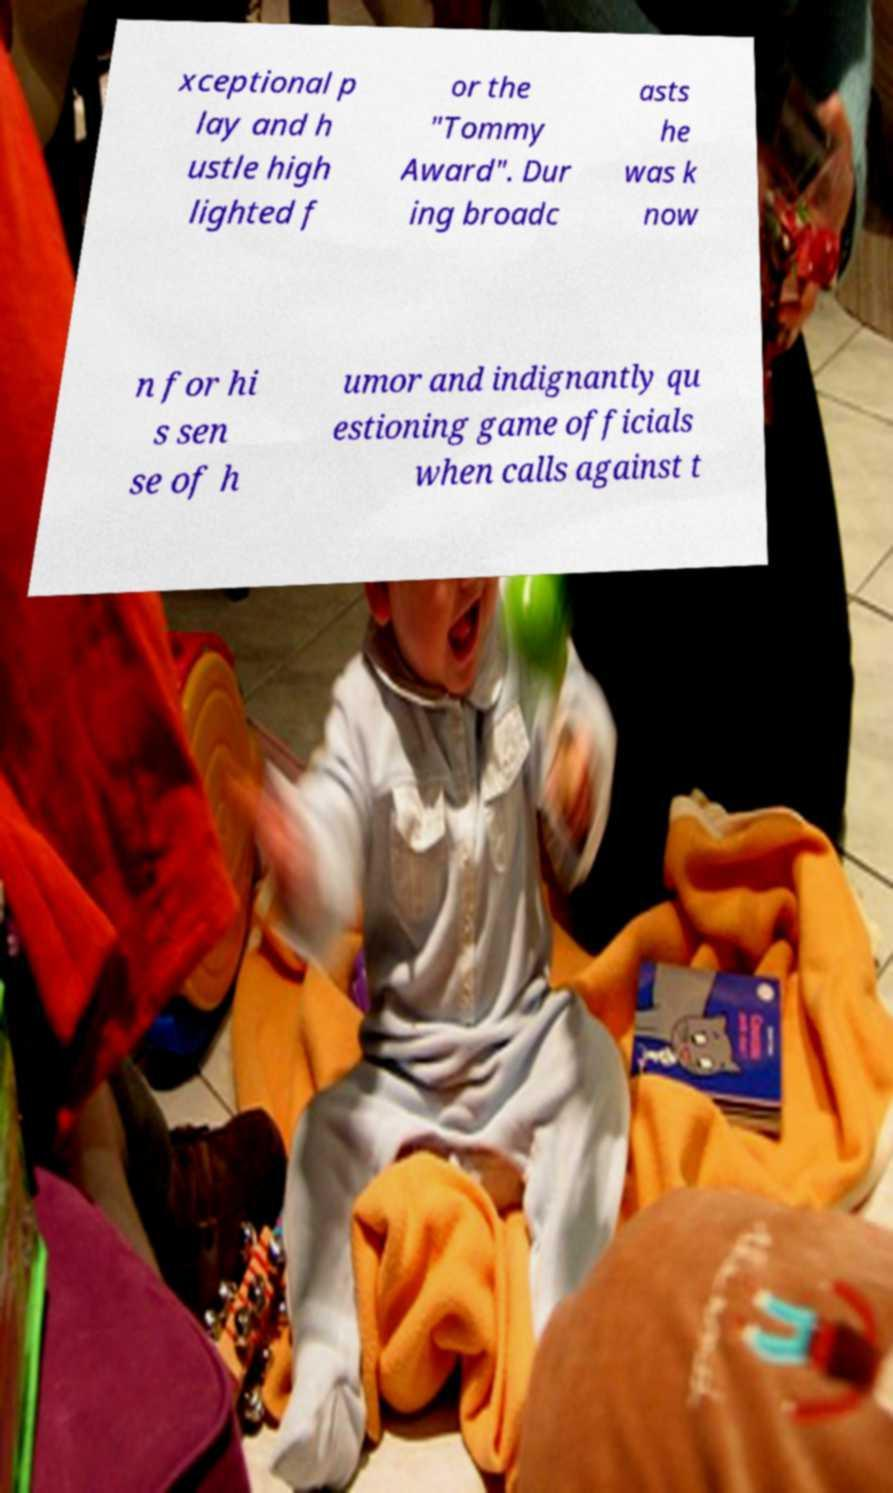I need the written content from this picture converted into text. Can you do that? xceptional p lay and h ustle high lighted f or the "Tommy Award". Dur ing broadc asts he was k now n for hi s sen se of h umor and indignantly qu estioning game officials when calls against t 